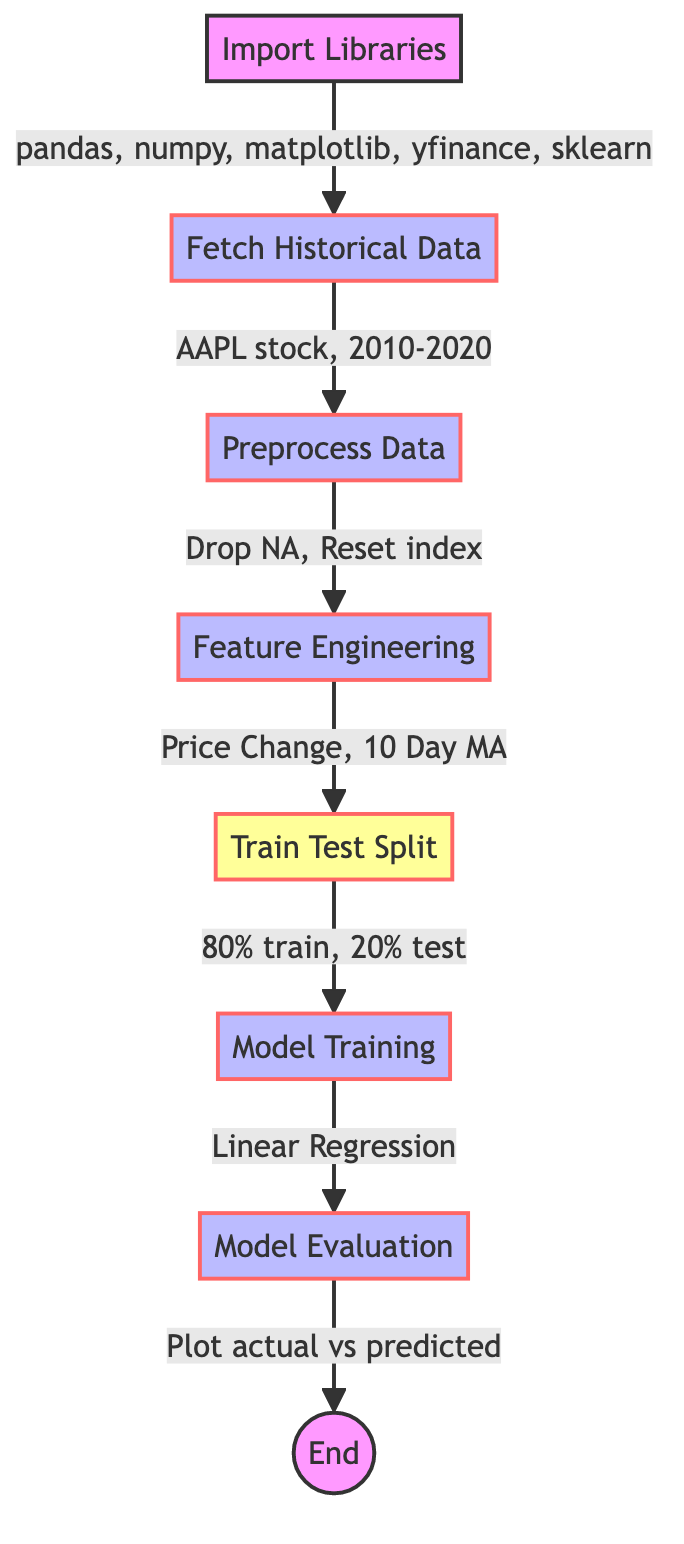What is the first step in the flowchart? The first step is "Import Libraries," which is indicated as the starting point of the flowchart.
Answer: Import Libraries How many main processes are present in the flowchart? The flowchart consists of six main processes after the initial import, including fetching data, preprocessing, feature engineering, model training, and model evaluation.
Answer: Six What type of model is used in the Model Training step? The flowchart specifies that the model used is "Linear Regression," as labeled in the Model Training process.
Answer: Linear Regression Which data is specifically fetched in the Fetch Historical Data step? The Fetch Historical Data step mentions the ticker "AAPL" corresponding to Apple Inc. stock over a specified date range from 2010 to 2020.
Answer: AAPL stock What happens to the data in the Preprocess Data step? In the Preprocess Data step, the flowchart indicates that the data is cleaned by dropping any missing values and resetting the index, hence preparing it for analysis.
Answer: Drop NA, Reset index In which step is the data split into training and testing sets? The "Train Test Split" step of the flowchart indicates that the data is divided into 80% for training and 20% for testing.
Answer: Train Test Split What is plotted in the Model Evaluation step? The Model Evaluation step describes that both the actual and predicted stock prices are plotted against the dates, emphasizing the comparison of predictions with actual values.
Answer: Actual vs predicted What is the last step indicated in the flowchart? The flowchart concludes with the node labeled "End," representing the completion of the process.
Answer: End What percentage of the data is used for training according to the diagram? The "Train Test Split" step specifies that 80% of the data is allocated for training purposes.
Answer: Eighty percent 